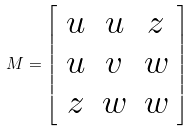<formula> <loc_0><loc_0><loc_500><loc_500>M = \left [ \begin{array} { c c c } { u } & { u } & { z } \\ { u } & { v } & { w } \\ { z } & { w } & { w } \end{array} \right ]</formula> 